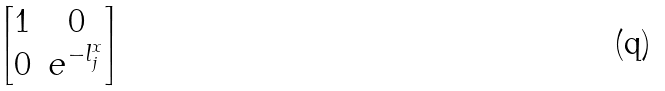Convert formula to latex. <formula><loc_0><loc_0><loc_500><loc_500>\begin{bmatrix} 1 & 0 \\ 0 & e ^ { - l _ { j } ^ { x } } \end{bmatrix}</formula> 